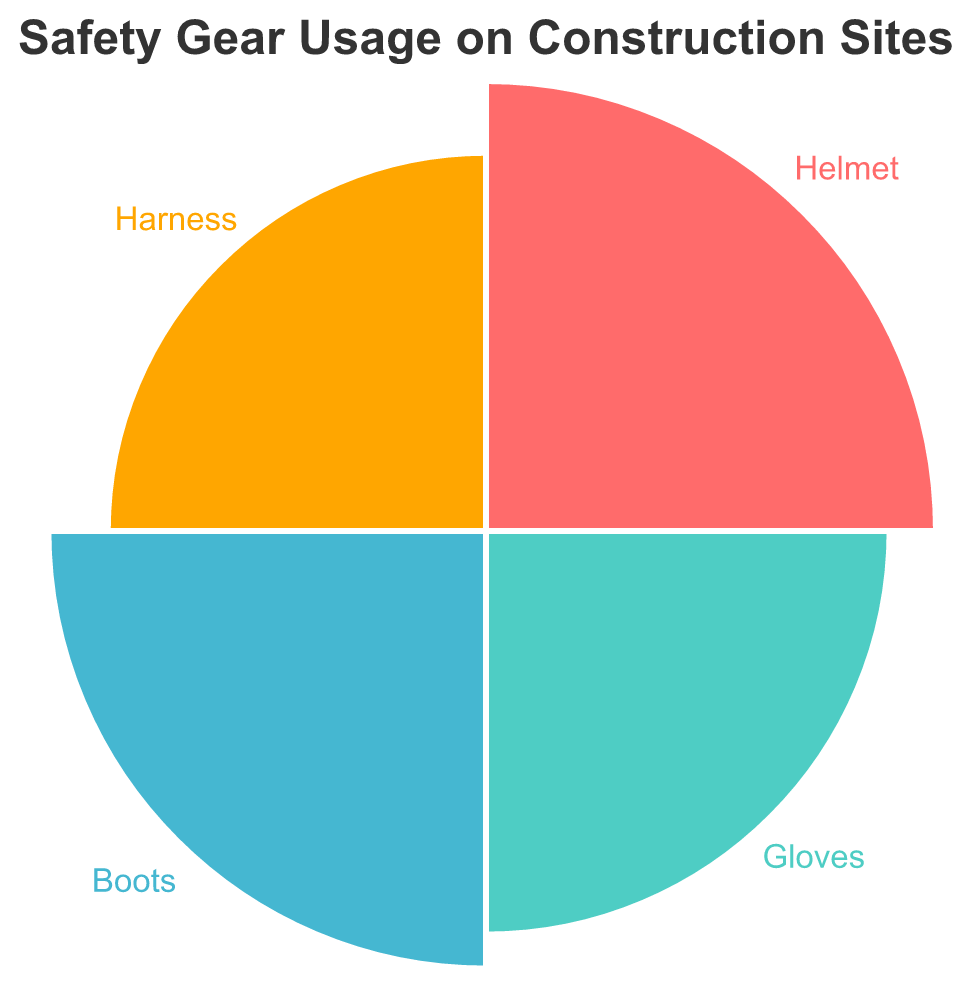1. What is the title of the chart? The title of the chart is displayed at the top, easy to identify when looking at the figure.
Answer: Safety Gear Usage on Construction Sites 2. Which safety gear has the highest usage percentage? The segment with the largest radius on the polar chart should represent the highest percentage.
Answer: Helmet 3. How many different types of safety gear are displayed? By counting the number of different segments or labels around the polar chart.
Answer: Four 4. What is the percentage of workers using gloves? Locate the segment labeled "Gloves" on the chart and observe the associated percentage.
Answer: 74% 5. How much higher is the percentage of workers using helmets compared to the percentage using harnesses? Subtract the percentage of harness usage from the percentage of helmet usage (92 - 65).
Answer: 27% 6. Which safety gear has the lowest usage percentage? Identify the segment with the smallest radius, which represents the lowest percentage.
Answer: Harness 7. What is the average percentage of workers using safety gear? Add the percentages of all safety gear (92 + 74 + 87 + 65) and divide by the number of gear types (4).
Answer: 79.5% 8. Are more workers using boots or gloves? Compare the percentages of workers using boots and gloves, looking at their respective segments.
Answer: Boots 9. What is the combined percentage of workers using helmets and gloves? Add the percentages of workers using helmets and gloves (92 + 74).
Answer: 166% 10. In terms of percentage, which safety gear is closest in usage to gloves? Compare the percentage of gloves (74%) to the other gear (92%, 87%, and 65%) to find the closest value.
Answer: Boots 